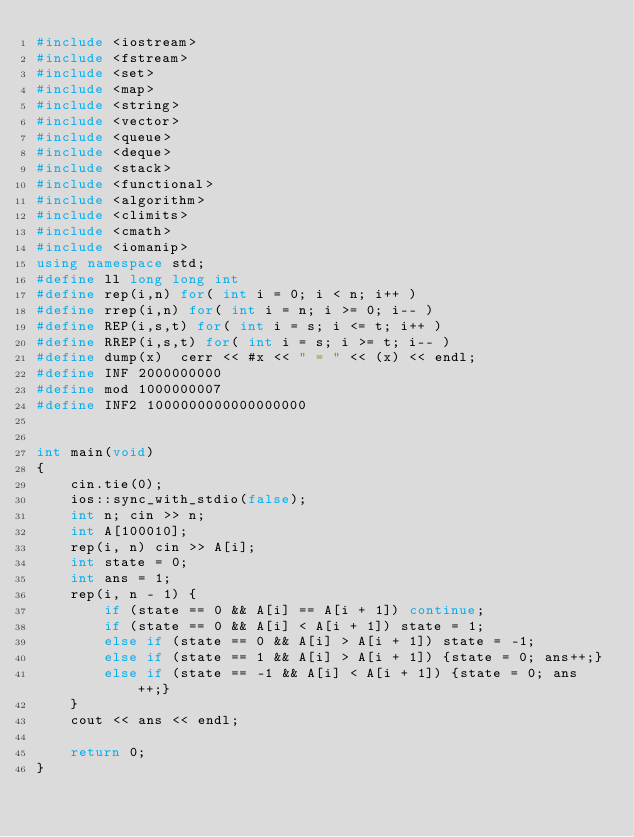Convert code to text. <code><loc_0><loc_0><loc_500><loc_500><_C++_>#include <iostream>
#include <fstream>
#include <set>
#include <map>
#include <string>
#include <vector>
#include <queue>
#include <deque>
#include <stack>
#include <functional>
#include <algorithm>
#include <climits>
#include <cmath>
#include <iomanip>
using namespace std;
#define ll long long int
#define rep(i,n) for( int i = 0; i < n; i++ )
#define rrep(i,n) for( int i = n; i >= 0; i-- )
#define REP(i,s,t) for( int i = s; i <= t; i++ )
#define RREP(i,s,t) for( int i = s; i >= t; i-- )
#define dump(x)  cerr << #x << " = " << (x) << endl;
#define INF 2000000000
#define mod 1000000007
#define INF2 1000000000000000000


int main(void)
{
    cin.tie(0);
    ios::sync_with_stdio(false);
    int n; cin >> n;
    int A[100010];
    rep(i, n) cin >> A[i];
    int state = 0;
    int ans = 1;
    rep(i, n - 1) {
        if (state == 0 && A[i] == A[i + 1]) continue;
        if (state == 0 && A[i] < A[i + 1]) state = 1;
        else if (state == 0 && A[i] > A[i + 1]) state = -1;
        else if (state == 1 && A[i] > A[i + 1]) {state = 0; ans++;}
        else if (state == -1 && A[i] < A[i + 1]) {state = 0; ans++;}
    }
    cout << ans << endl;

    return 0;
}
</code> 